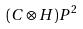<formula> <loc_0><loc_0><loc_500><loc_500>( C \otimes H ) P ^ { 2 }</formula> 